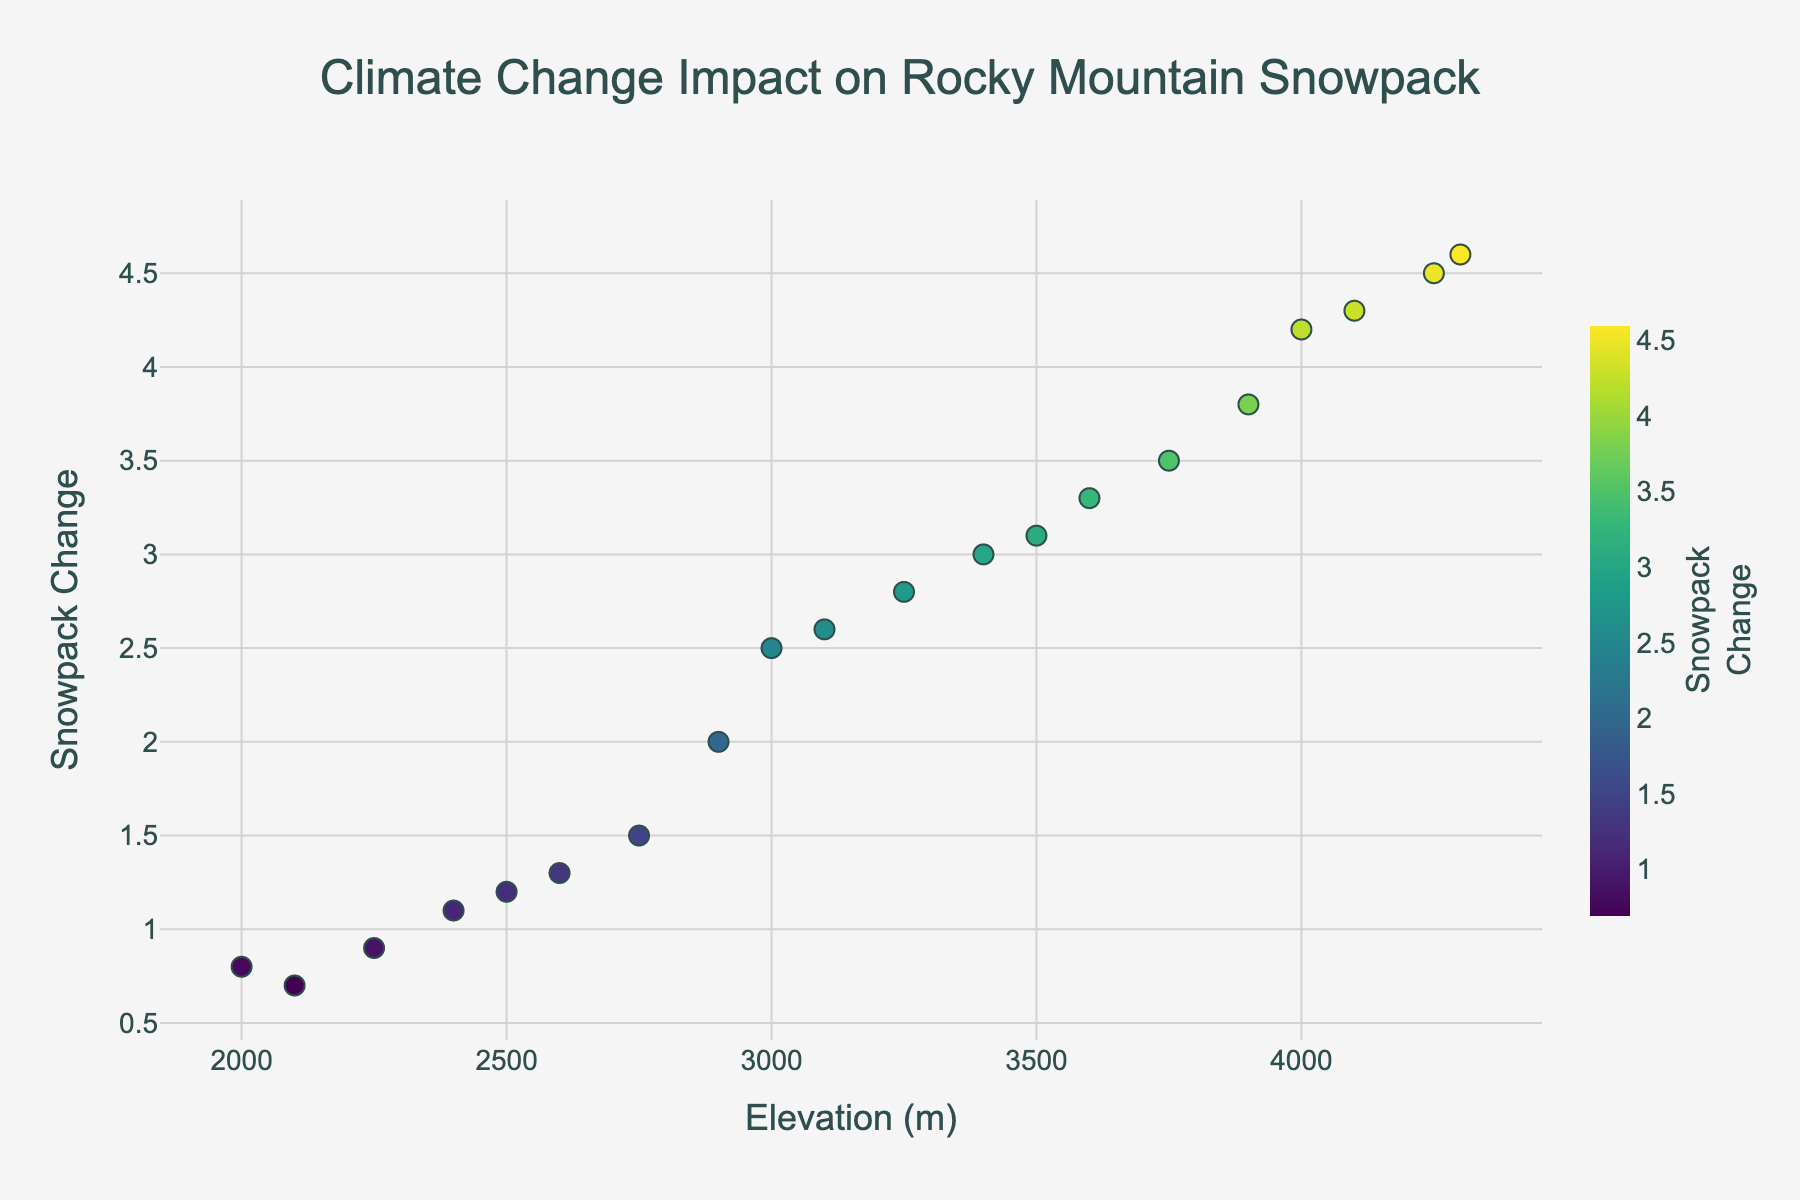what is the title of the plot? The title of the plot is located at the top of the figure and typically describes the overall purpose or finding of the visualization. In this case, the title is "Climate Change Impact on Rocky Mountain Snowpack".
Answer: Climate Change Impact on Rocky Mountain Snowpack What is the y-axis representing in this plot? The y-axis title is visually labeled on the left side of the plot. In this case, it is labeled as "Snowpack Change", representing the variation in snowpack levels due to climate change.
Answer: Snowpack Change How many data points are there in the plot? By counting the number of markers on the plot, we can determine the number of data points. There are 20 data markers in the plot.
Answer: 20 Which elevation has the highest snowpack change? By looking at the plot, you can identify the data point with the highest position on the y-axis. The elevation corresponding to this point is 4300 meters.
Answer: 4300 meters What is the range of snowpack change observed in the plot? The range can be determined by subtracting the minimum value from the maximum value observed on the y-axis. The maximum value is approximately 4.6, and the minimum value is approximately 0.7. Therefore, the range is 4.6 - 0.7 = 3.9.
Answer: 3.9 What's the difference in snowpack change between 3000 meters and 3500 meters? To find this, identify the snowpack change at 3000 meters (which is approximately 2.5) and at 3500 meters (which is approximately 3.1). Then, subtract the 3000 meters value from the 3500 meters value. 3.1 - 2.5 = 0.6.
Answer: 0.6 Which elevation range shows the most significant increase in snowpack change? Observe the gradient or slope between data points. The largest jump in snowpack change value appears between 4000 meters and 4250 meters. From the data, the change is from 4.2 to 4.5, i.e., 0.3.
Answer: 4000 meters to 4250 meters What's the average snowpack change for elevations above 3000 meters? Identify elevations above 3000 meters and calculate their associated snowpack changes: 2.5 (3000), 3.1 (3500), 4.2 (4000), 2.8 (3250), 3.5 (3750), 4.5 (4250), 2.6 (3100), 3.3 (3600), 4.3 (4100), 3.0 (3400), 3.8 (3900), 4.6 (4300). Sum these values = 40.2; then divide by the number of data points (12). 40.2 / 12 ≈ 3.35.
Answer: 3.35 Do higher elevations generally have higher snowpack changes? To answer this, observe the trend in the plot. Higher elevations tend to have higher snowpack changes based on the observed data points as the trend on the plot shows an upward pattern as elevation increases.
Answer: Yes What's the snowpack change at the lowest elevation presented? The lowest elevation shown is 2000 meters. According to the plot, the snowpack change at this elevation is approximately 0.8.
Answer: 0.8 